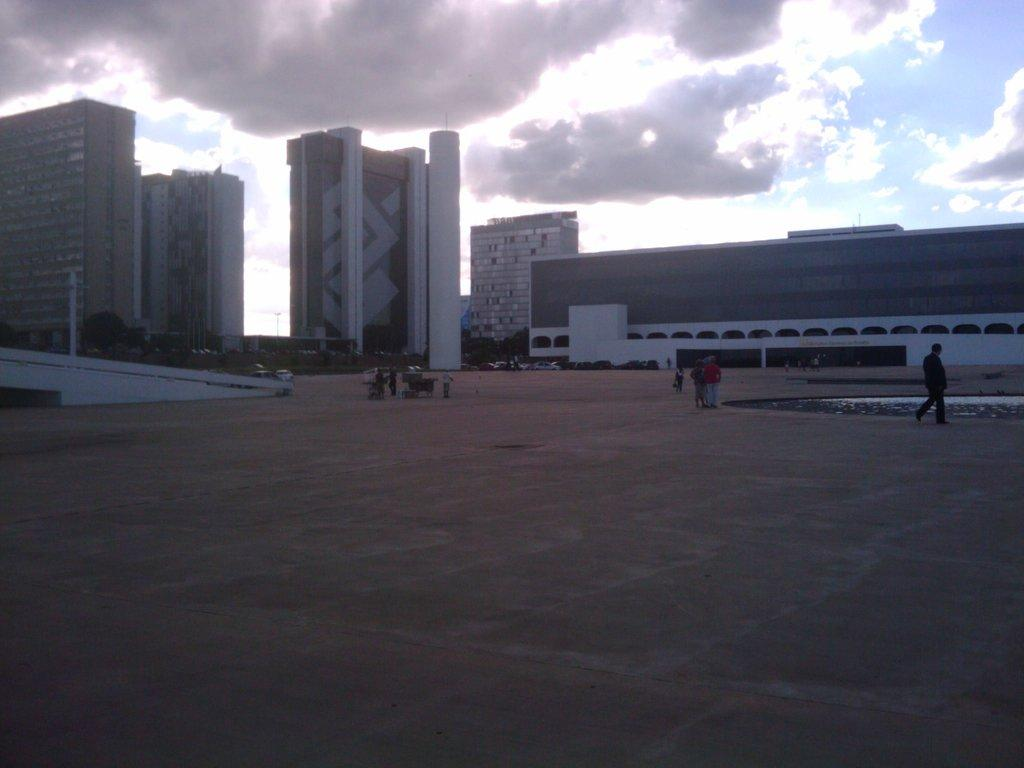What is the main subject of the image? The main subject of the image is the buildings at the center. What is happening in front of the buildings? There are people walking in front of the buildings. What can be seen in the background of the image? The sky is visible in the background of the image. What type of skate is being used by the beast in the image? There is no skate or beast present in the image. 